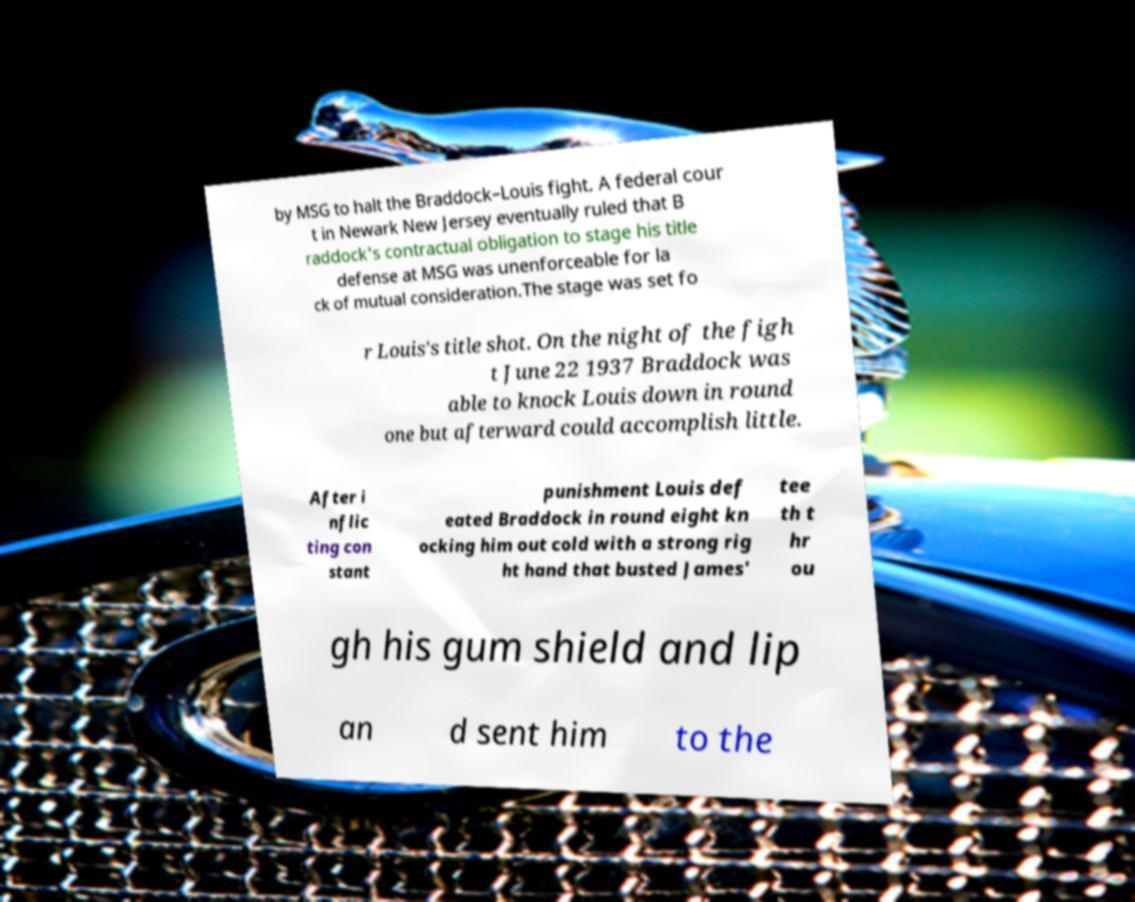Can you accurately transcribe the text from the provided image for me? by MSG to halt the Braddock–Louis fight. A federal cour t in Newark New Jersey eventually ruled that B raddock's contractual obligation to stage his title defense at MSG was unenforceable for la ck of mutual consideration.The stage was set fo r Louis's title shot. On the night of the figh t June 22 1937 Braddock was able to knock Louis down in round one but afterward could accomplish little. After i nflic ting con stant punishment Louis def eated Braddock in round eight kn ocking him out cold with a strong rig ht hand that busted James' tee th t hr ou gh his gum shield and lip an d sent him to the 